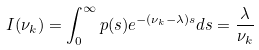<formula> <loc_0><loc_0><loc_500><loc_500>I ( \nu _ { k } ) = \int _ { 0 } ^ { \infty } p ( s ) e ^ { - ( \nu _ { k } - \lambda ) s } d s = \frac { \lambda } { \nu _ { k } }</formula> 